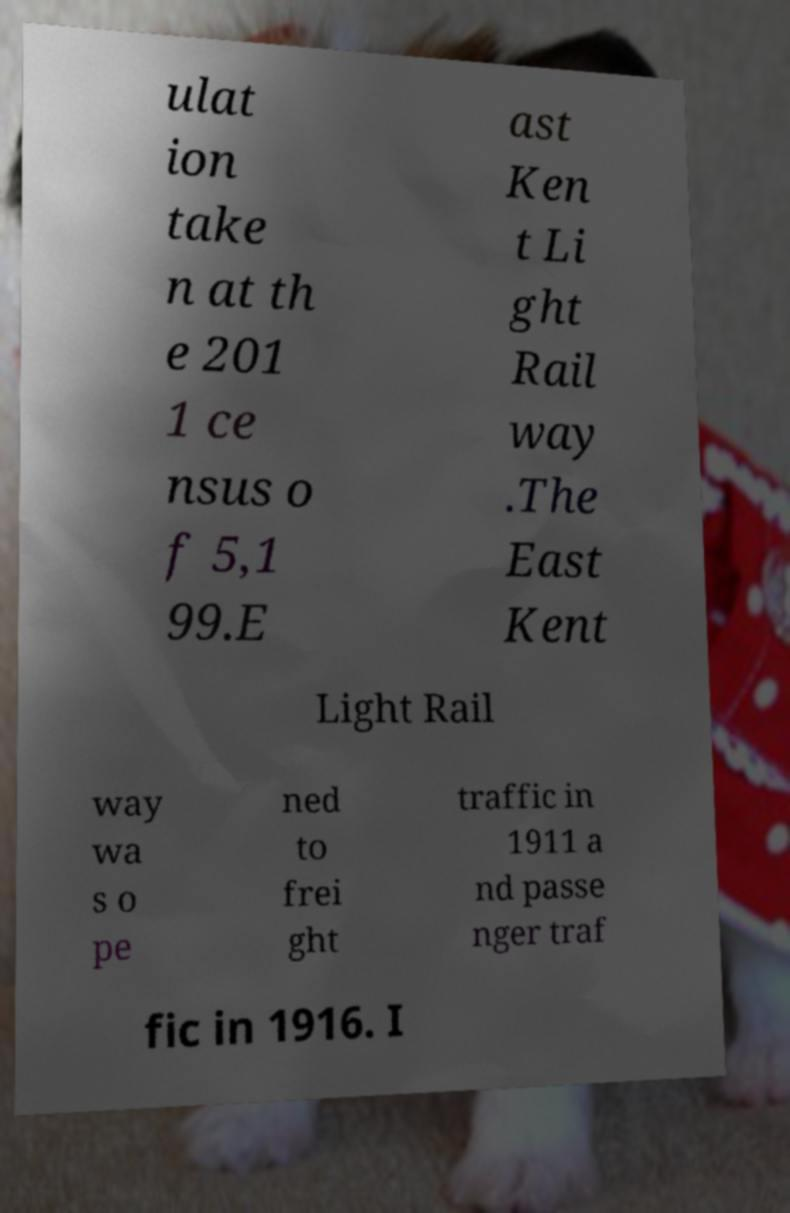Could you extract and type out the text from this image? ulat ion take n at th e 201 1 ce nsus o f 5,1 99.E ast Ken t Li ght Rail way .The East Kent Light Rail way wa s o pe ned to frei ght traffic in 1911 a nd passe nger traf fic in 1916. I 